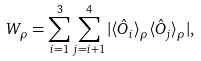<formula> <loc_0><loc_0><loc_500><loc_500>W _ { \rho } = \sum _ { i = 1 } ^ { 3 } \sum _ { j = i + 1 } ^ { 4 } | \langle \hat { O } _ { i } \rangle _ { \rho } \langle \hat { O } _ { j } \rangle _ { \rho } | ,</formula> 